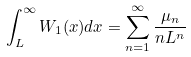<formula> <loc_0><loc_0><loc_500><loc_500>\int _ { L } ^ { \infty } W _ { 1 } ( x ) d x = \sum _ { n = 1 } ^ { \infty } \frac { \mu _ { n } } { n L ^ { n } }</formula> 